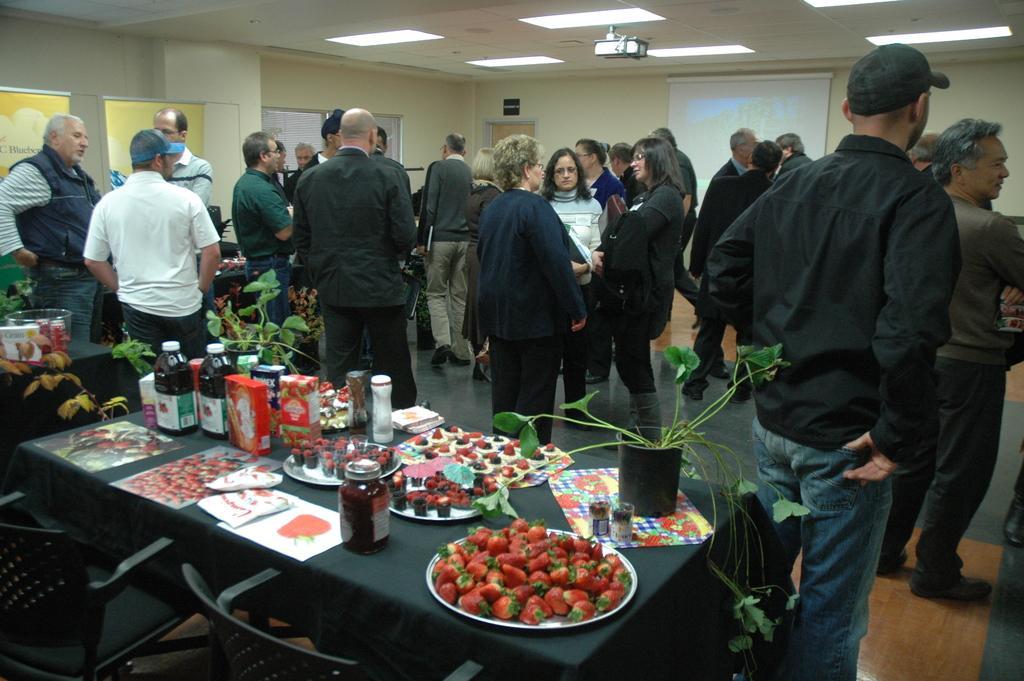Could you give a brief overview of what you see in this image? In this image we can see a group of people standing on the floor. On the bottom of the image we can see some chairs and a table containing some papers, bottles, boxes, cakes in a plate, plants in a pot, strawberries in a plate which are placed on it. On the backside we can see a wall, banners and a roof with some ceiling lights. 